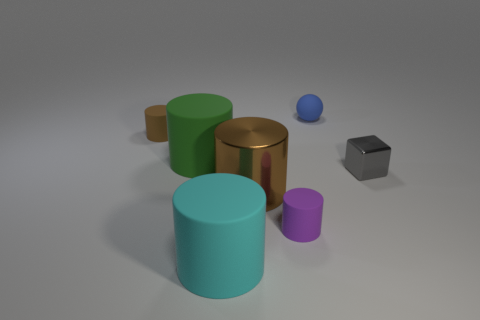Can you tell me the number of objects that have reflective surfaces? Certainly! In the image, there are two objects with reflective surfaces: a golden cylinder and a silver cube. 